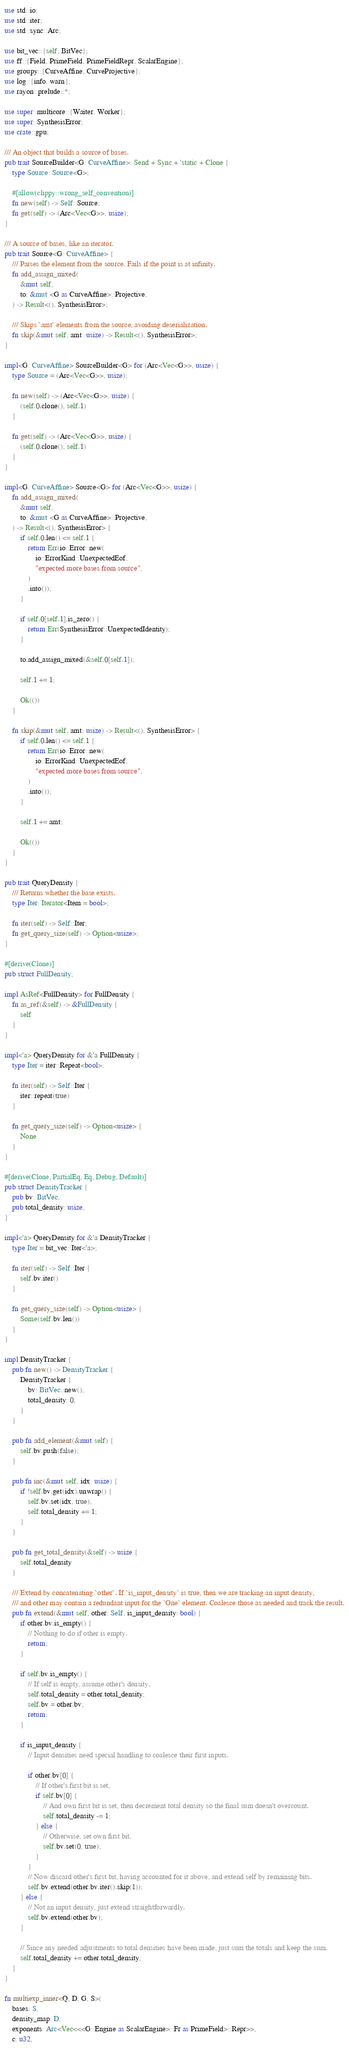Convert code to text. <code><loc_0><loc_0><loc_500><loc_500><_Rust_>use std::io;
use std::iter;
use std::sync::Arc;

use bit_vec::{self, BitVec};
use ff::{Field, PrimeField, PrimeFieldRepr, ScalarEngine};
use groupy::{CurveAffine, CurveProjective};
use log::{info, warn};
use rayon::prelude::*;

use super::multicore::{Waiter, Worker};
use super::SynthesisError;
use crate::gpu;

/// An object that builds a source of bases.
pub trait SourceBuilder<G: CurveAffine>: Send + Sync + 'static + Clone {
    type Source: Source<G>;

    #[allow(clippy::wrong_self_convention)]
    fn new(self) -> Self::Source;
    fn get(self) -> (Arc<Vec<G>>, usize);
}

/// A source of bases, like an iterator.
pub trait Source<G: CurveAffine> {
    /// Parses the element from the source. Fails if the point is at infinity.
    fn add_assign_mixed(
        &mut self,
        to: &mut <G as CurveAffine>::Projective,
    ) -> Result<(), SynthesisError>;

    /// Skips `amt` elements from the source, avoiding deserialization.
    fn skip(&mut self, amt: usize) -> Result<(), SynthesisError>;
}

impl<G: CurveAffine> SourceBuilder<G> for (Arc<Vec<G>>, usize) {
    type Source = (Arc<Vec<G>>, usize);

    fn new(self) -> (Arc<Vec<G>>, usize) {
        (self.0.clone(), self.1)
    }

    fn get(self) -> (Arc<Vec<G>>, usize) {
        (self.0.clone(), self.1)
    }
}

impl<G: CurveAffine> Source<G> for (Arc<Vec<G>>, usize) {
    fn add_assign_mixed(
        &mut self,
        to: &mut <G as CurveAffine>::Projective,
    ) -> Result<(), SynthesisError> {
        if self.0.len() <= self.1 {
            return Err(io::Error::new(
                io::ErrorKind::UnexpectedEof,
                "expected more bases from source",
            )
            .into());
        }

        if self.0[self.1].is_zero() {
            return Err(SynthesisError::UnexpectedIdentity);
        }

        to.add_assign_mixed(&self.0[self.1]);

        self.1 += 1;

        Ok(())
    }

    fn skip(&mut self, amt: usize) -> Result<(), SynthesisError> {
        if self.0.len() <= self.1 {
            return Err(io::Error::new(
                io::ErrorKind::UnexpectedEof,
                "expected more bases from source",
            )
            .into());
        }

        self.1 += amt;

        Ok(())
    }
}

pub trait QueryDensity {
    /// Returns whether the base exists.
    type Iter: Iterator<Item = bool>;

    fn iter(self) -> Self::Iter;
    fn get_query_size(self) -> Option<usize>;
}

#[derive(Clone)]
pub struct FullDensity;

impl AsRef<FullDensity> for FullDensity {
    fn as_ref(&self) -> &FullDensity {
        self
    }
}

impl<'a> QueryDensity for &'a FullDensity {
    type Iter = iter::Repeat<bool>;

    fn iter(self) -> Self::Iter {
        iter::repeat(true)
    }

    fn get_query_size(self) -> Option<usize> {
        None
    }
}

#[derive(Clone, PartialEq, Eq, Debug, Default)]
pub struct DensityTracker {
    pub bv: BitVec,
    pub total_density: usize,
}

impl<'a> QueryDensity for &'a DensityTracker {
    type Iter = bit_vec::Iter<'a>;

    fn iter(self) -> Self::Iter {
        self.bv.iter()
    }

    fn get_query_size(self) -> Option<usize> {
        Some(self.bv.len())
    }
}

impl DensityTracker {
    pub fn new() -> DensityTracker {
        DensityTracker {
            bv: BitVec::new(),
            total_density: 0,
        }
    }

    pub fn add_element(&mut self) {
        self.bv.push(false);
    }

    pub fn inc(&mut self, idx: usize) {
        if !self.bv.get(idx).unwrap() {
            self.bv.set(idx, true);
            self.total_density += 1;
        }
    }

    pub fn get_total_density(&self) -> usize {
        self.total_density
    }

    /// Extend by concatenating `other`. If `is_input_density` is true, then we are tracking an input density,
    /// and other may contain a redundant input for the `One` element. Coalesce those as needed and track the result.
    pub fn extend(&mut self, other: Self, is_input_density: bool) {
        if other.bv.is_empty() {
            // Nothing to do if other is empty.
            return;
        }

        if self.bv.is_empty() {
            // If self is empty, assume other's density.
            self.total_density = other.total_density;
            self.bv = other.bv;
            return;
        }

        if is_input_density {
            // Input densities need special handling to coalesce their first inputs.

            if other.bv[0] {
                // If other's first bit is set,
                if self.bv[0] {
                    // And own first bit is set, then decrement total density so the final sum doesn't overcount.
                    self.total_density -= 1;
                } else {
                    // Otherwise, set own first bit.
                    self.bv.set(0, true);
                }
            }
            // Now discard other's first bit, having accounted for it above, and extend self by remaining bits.
            self.bv.extend(other.bv.iter().skip(1));
        } else {
            // Not an input density, just extend straightforwardly.
            self.bv.extend(other.bv);
        }

        // Since any needed adjustments to total densities have been made, just sum the totals and keep the sum.
        self.total_density += other.total_density;
    }
}

fn multiexp_inner<Q, D, G, S>(
    bases: S,
    density_map: D,
    exponents: Arc<Vec<<<G::Engine as ScalarEngine>::Fr as PrimeField>::Repr>>,
    c: u32,</code> 